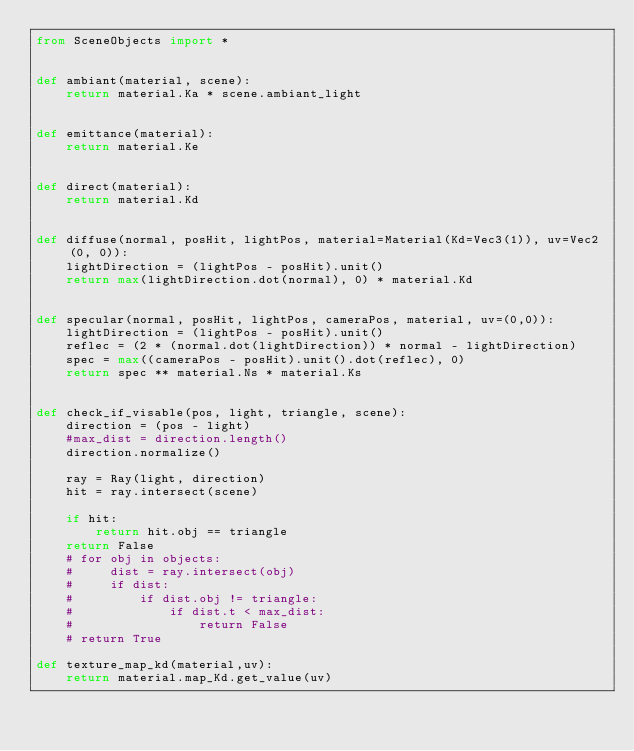Convert code to text. <code><loc_0><loc_0><loc_500><loc_500><_Python_>from SceneObjects import *


def ambiant(material, scene):
    return material.Ka * scene.ambiant_light


def emittance(material):
    return material.Ke


def direct(material):
    return material.Kd


def diffuse(normal, posHit, lightPos, material=Material(Kd=Vec3(1)), uv=Vec2(0, 0)):
    lightDirection = (lightPos - posHit).unit()
    return max(lightDirection.dot(normal), 0) * material.Kd


def specular(normal, posHit, lightPos, cameraPos, material, uv=(0,0)):
    lightDirection = (lightPos - posHit).unit()
    reflec = (2 * (normal.dot(lightDirection)) * normal - lightDirection)
    spec = max((cameraPos - posHit).unit().dot(reflec), 0)
    return spec ** material.Ns * material.Ks


def check_if_visable(pos, light, triangle, scene):
    direction = (pos - light)
    #max_dist = direction.length()
    direction.normalize()

    ray = Ray(light, direction)
    hit = ray.intersect(scene)

    if hit:
        return hit.obj == triangle
    return False
    # for obj in objects:
    #     dist = ray.intersect(obj)
    #     if dist:
    #         if dist.obj != triangle:
    #             if dist.t < max_dist:
    #                 return False
    # return True

def texture_map_kd(material,uv):
    return material.map_Kd.get_value(uv)
</code> 